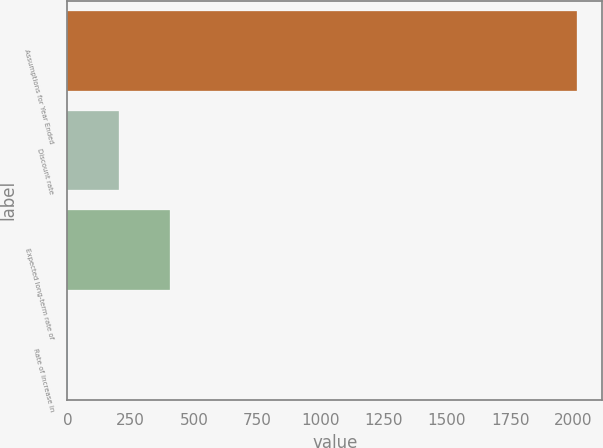<chart> <loc_0><loc_0><loc_500><loc_500><bar_chart><fcel>Assumptions for Year Ended<fcel>Discount rate<fcel>Expected long-term rate of<fcel>Rate of increase in<nl><fcel>2013<fcel>204.71<fcel>405.63<fcel>3.79<nl></chart> 